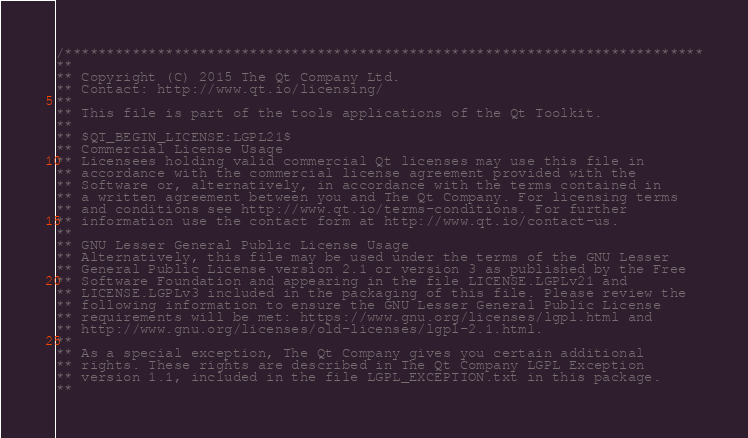Convert code to text. <code><loc_0><loc_0><loc_500><loc_500><_C_>/****************************************************************************
**
** Copyright (C) 2015 The Qt Company Ltd.
** Contact: http://www.qt.io/licensing/
**
** This file is part of the tools applications of the Qt Toolkit.
**
** $QT_BEGIN_LICENSE:LGPL21$
** Commercial License Usage
** Licensees holding valid commercial Qt licenses may use this file in
** accordance with the commercial license agreement provided with the
** Software or, alternatively, in accordance with the terms contained in
** a written agreement between you and The Qt Company. For licensing terms
** and conditions see http://www.qt.io/terms-conditions. For further
** information use the contact form at http://www.qt.io/contact-us.
**
** GNU Lesser General Public License Usage
** Alternatively, this file may be used under the terms of the GNU Lesser
** General Public License version 2.1 or version 3 as published by the Free
** Software Foundation and appearing in the file LICENSE.LGPLv21 and
** LICENSE.LGPLv3 included in the packaging of this file. Please review the
** following information to ensure the GNU Lesser General Public License
** requirements will be met: https://www.gnu.org/licenses/lgpl.html and
** http://www.gnu.org/licenses/old-licenses/lgpl-2.1.html.
**
** As a special exception, The Qt Company gives you certain additional
** rights. These rights are described in The Qt Company LGPL Exception
** version 1.1, included in the file LGPL_EXCEPTION.txt in this package.
**</code> 